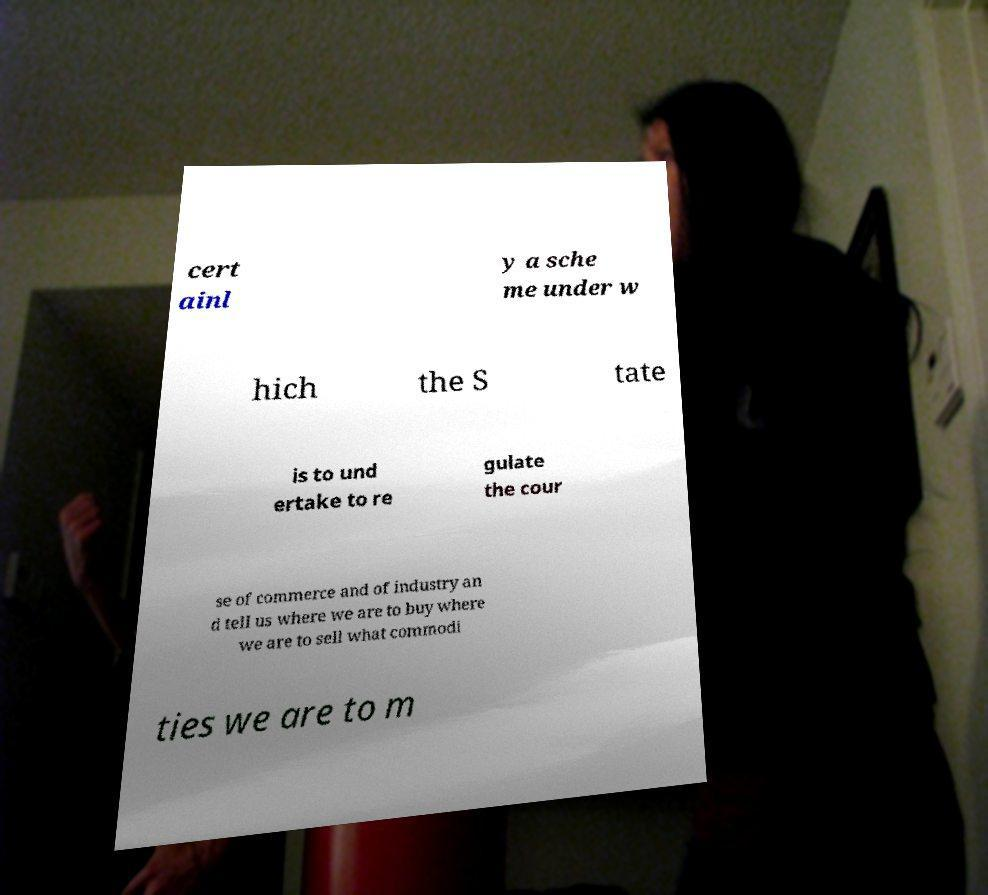Please identify and transcribe the text found in this image. cert ainl y a sche me under w hich the S tate is to und ertake to re gulate the cour se of commerce and of industry an d tell us where we are to buy where we are to sell what commodi ties we are to m 